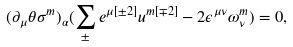Convert formula to latex. <formula><loc_0><loc_0><loc_500><loc_500>( \partial _ { \mu } \theta \sigma ^ { m } ) _ { \alpha } ( \sum _ { \pm } e ^ { \mu { [ \pm 2 ] } } u ^ { m [ \mp 2 ] } - 2 \epsilon ^ { \mu \nu } \omega _ { \nu } ^ { m } ) = 0 ,</formula> 